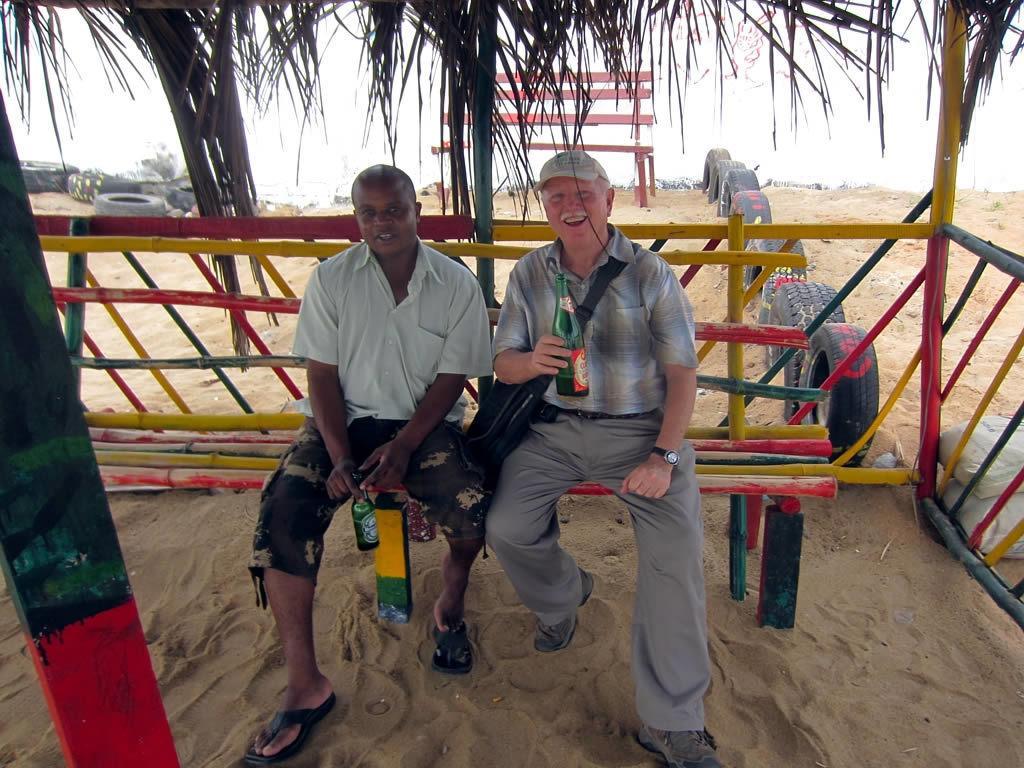Could you give a brief overview of what you see in this image? This picture is clicked outside. In the center we can see the two persons wearing shirts and sitting on the bench and holding the bottles of drinks and we can see a sling bag, wooden fence, tires, sand and some other items. In the background we can see the sky, green leaves, wooden planks and some other objects. 